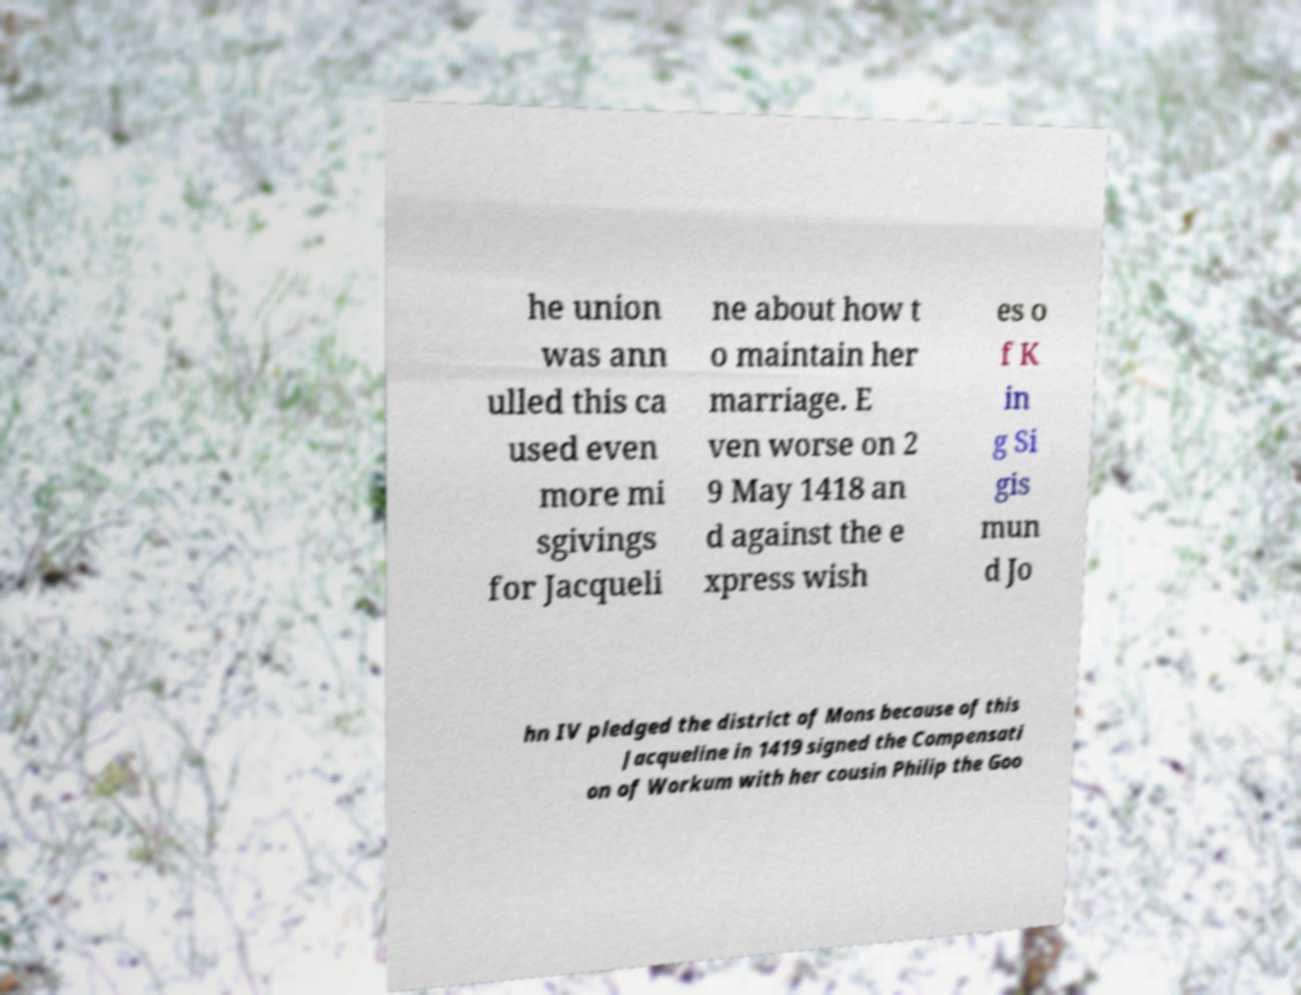Can you accurately transcribe the text from the provided image for me? he union was ann ulled this ca used even more mi sgivings for Jacqueli ne about how t o maintain her marriage. E ven worse on 2 9 May 1418 an d against the e xpress wish es o f K in g Si gis mun d Jo hn IV pledged the district of Mons because of this Jacqueline in 1419 signed the Compensati on of Workum with her cousin Philip the Goo 